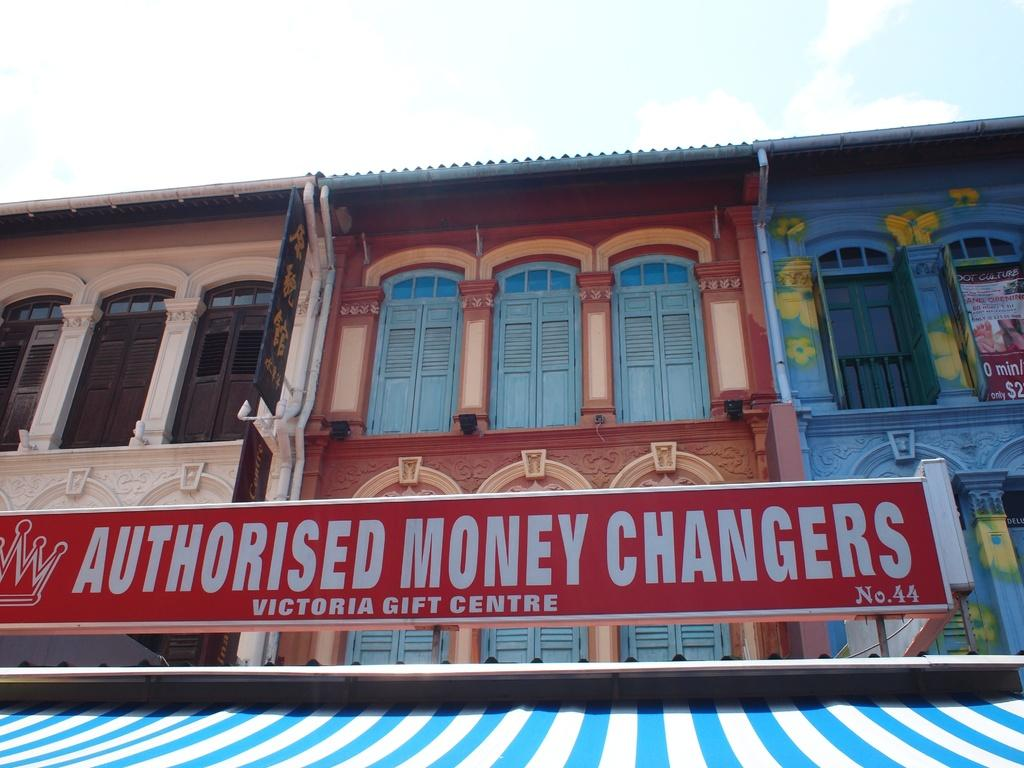What is the main focus of the image? The red color board is the main focus of the image. What else can be seen in the image besides the color board? There is a building in the image. Can you describe the building's appearance? The building has three colors: cream, maroon, and blue. What is visible in the background of the image? The sky is visible in the background of the image. What can be observed in the sky? Clouds are present in the sky. How many lizards are sitting on the color board in the image? There are no lizards present in the image. What type of weather can be observed in the image? The provided facts do not mention any weather conditions, so it cannot be determined from the image. 